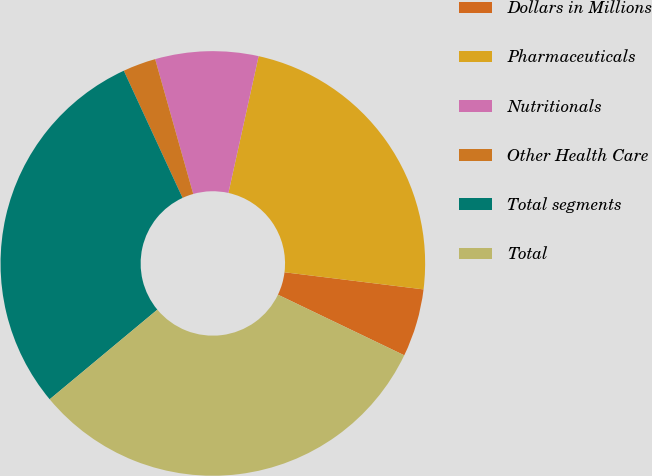<chart> <loc_0><loc_0><loc_500><loc_500><pie_chart><fcel>Dollars in Millions<fcel>Pharmaceuticals<fcel>Nutritionals<fcel>Other Health Care<fcel>Total segments<fcel>Total<nl><fcel>5.17%<fcel>23.49%<fcel>7.84%<fcel>2.51%<fcel>29.16%<fcel>31.83%<nl></chart> 